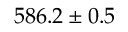Convert formula to latex. <formula><loc_0><loc_0><loc_500><loc_500>5 8 6 . 2 \pm 0 . 5</formula> 